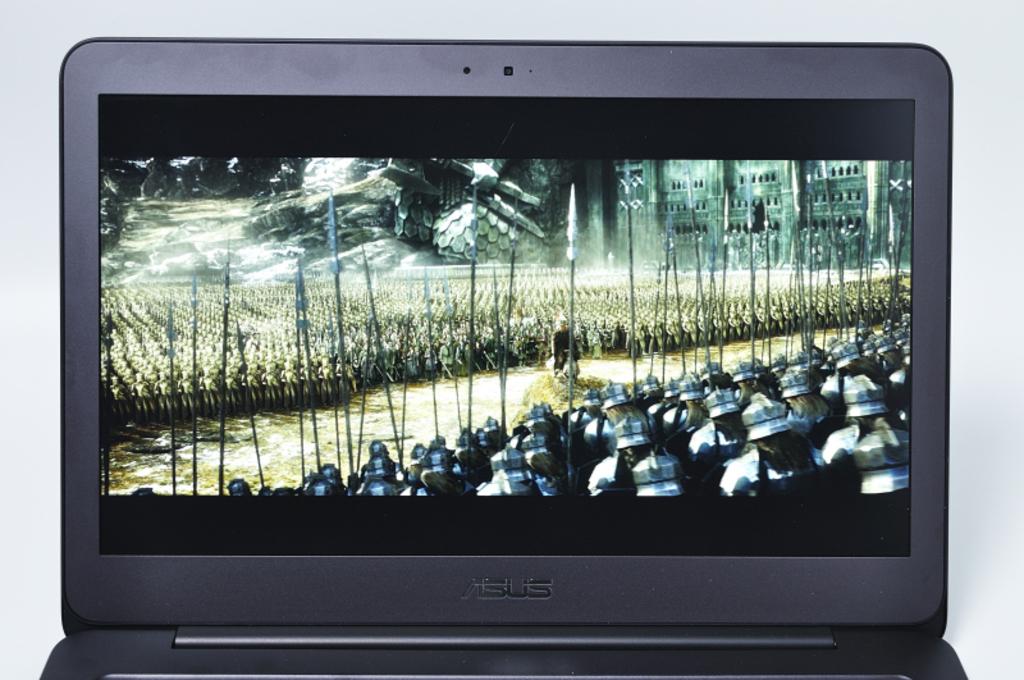What brand of laptop is this?
Give a very brief answer. Asus. How many letters are in the brands name?
Keep it short and to the point. 4. 